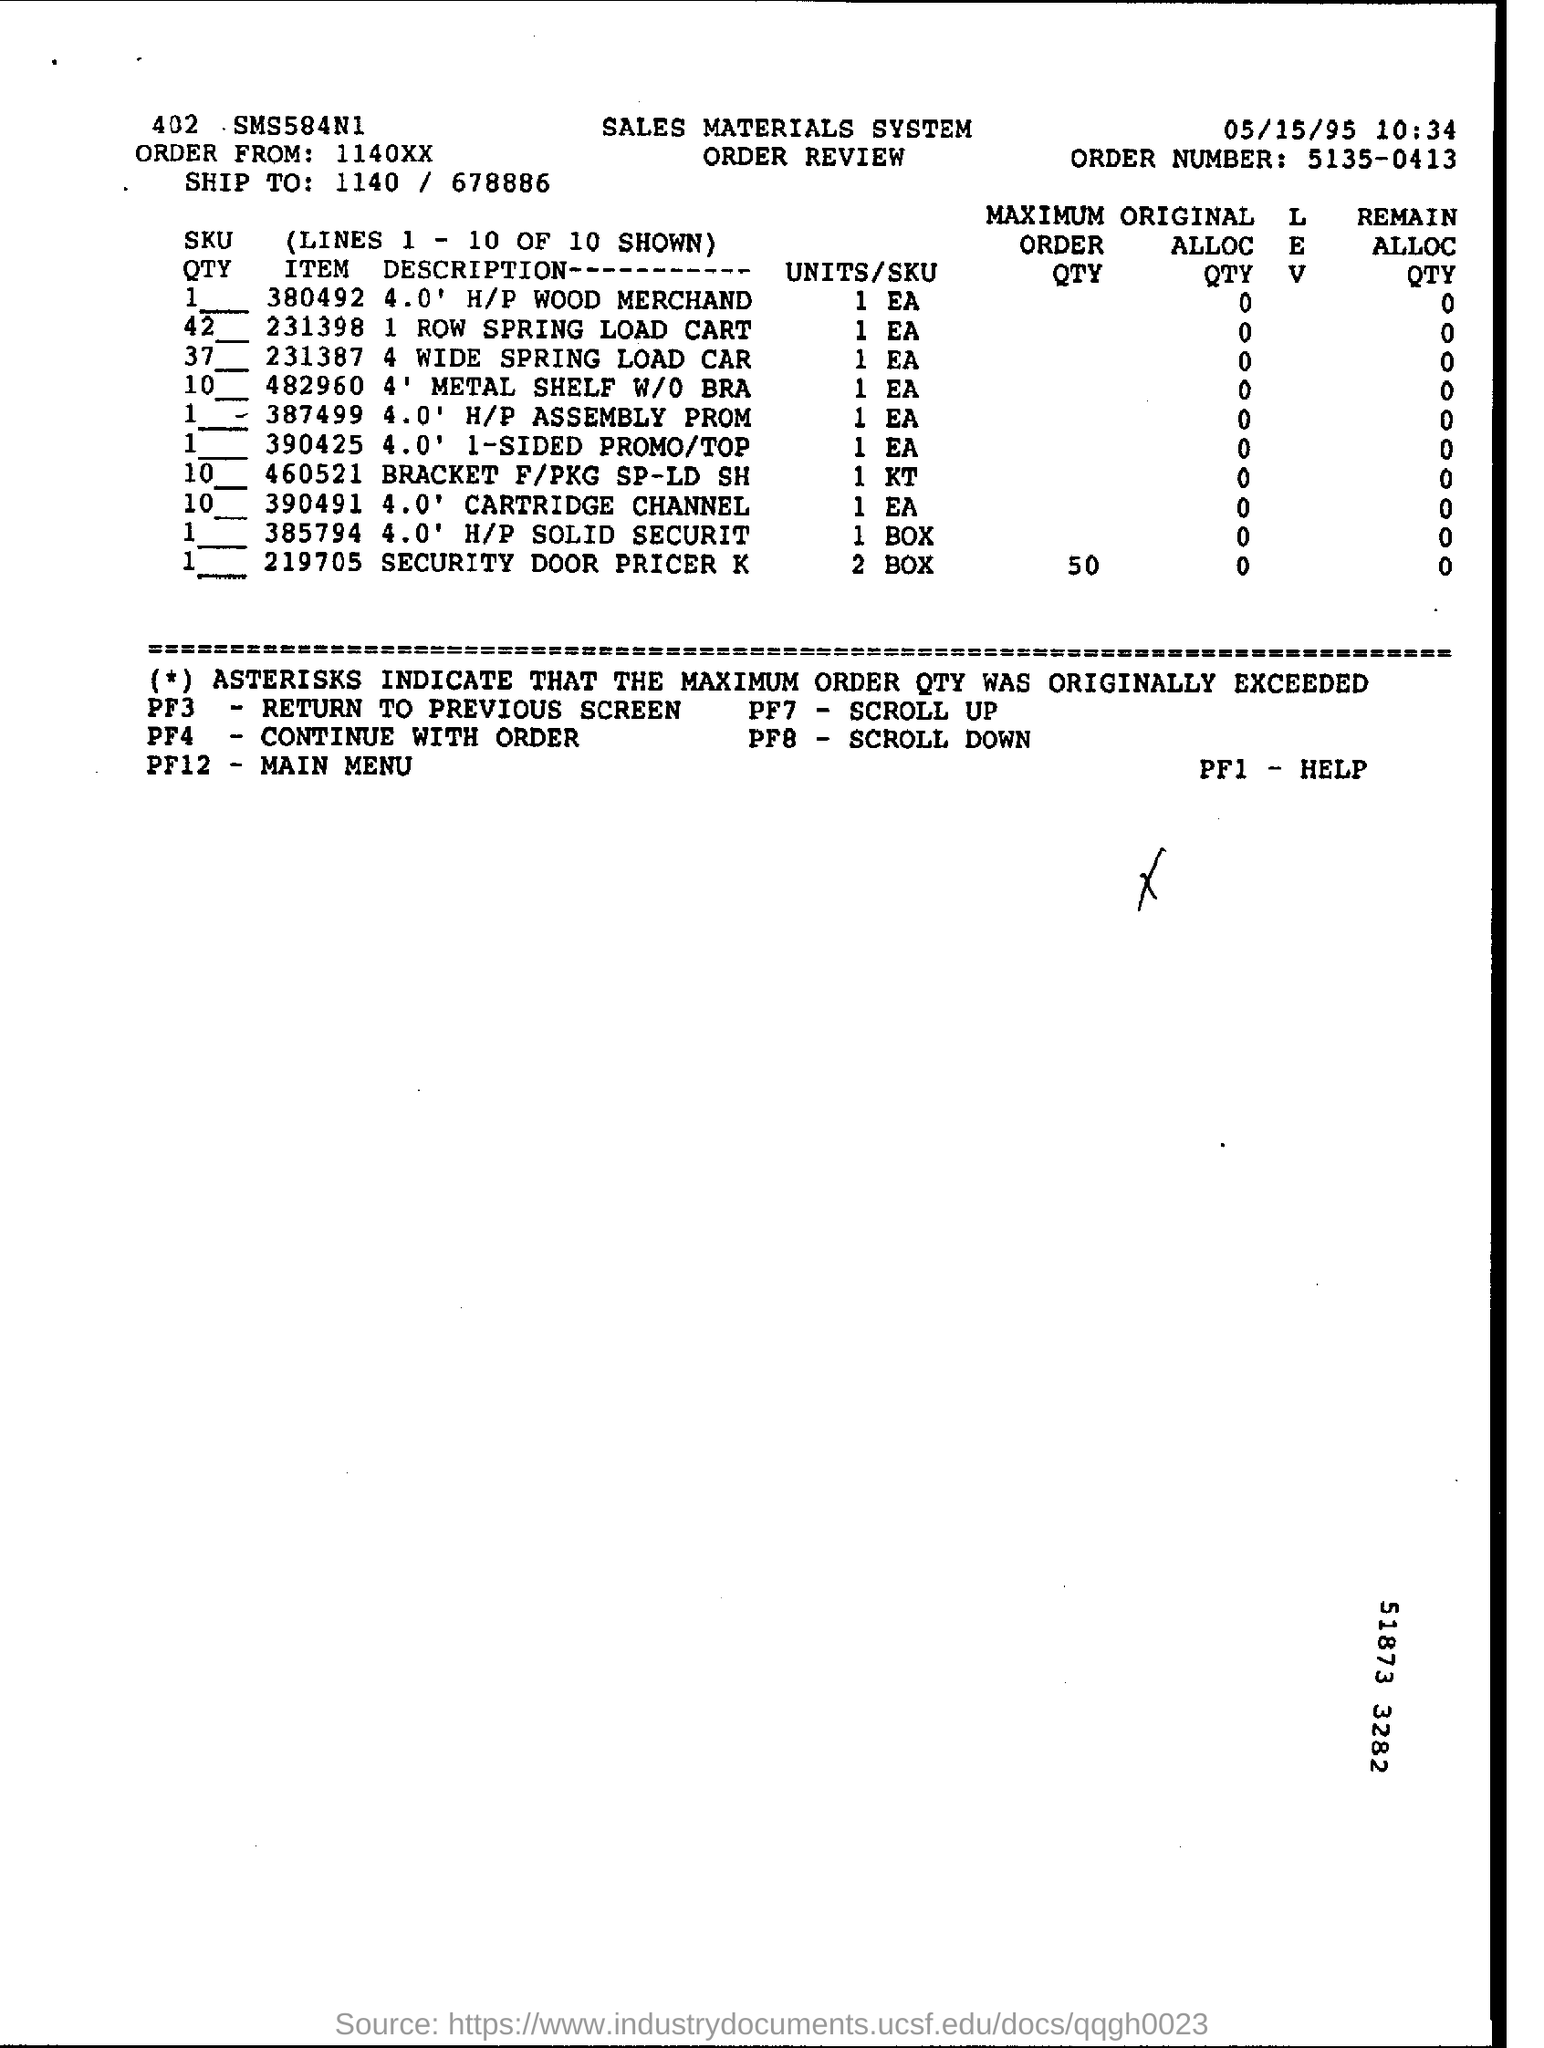Highlight a few significant elements in this photo. The order is from an address located at 1140xx... The maximum order quantity for item 219705 is 50. Please include the date at the top of the page as 05/15/95. The order number is 5135-0413. 